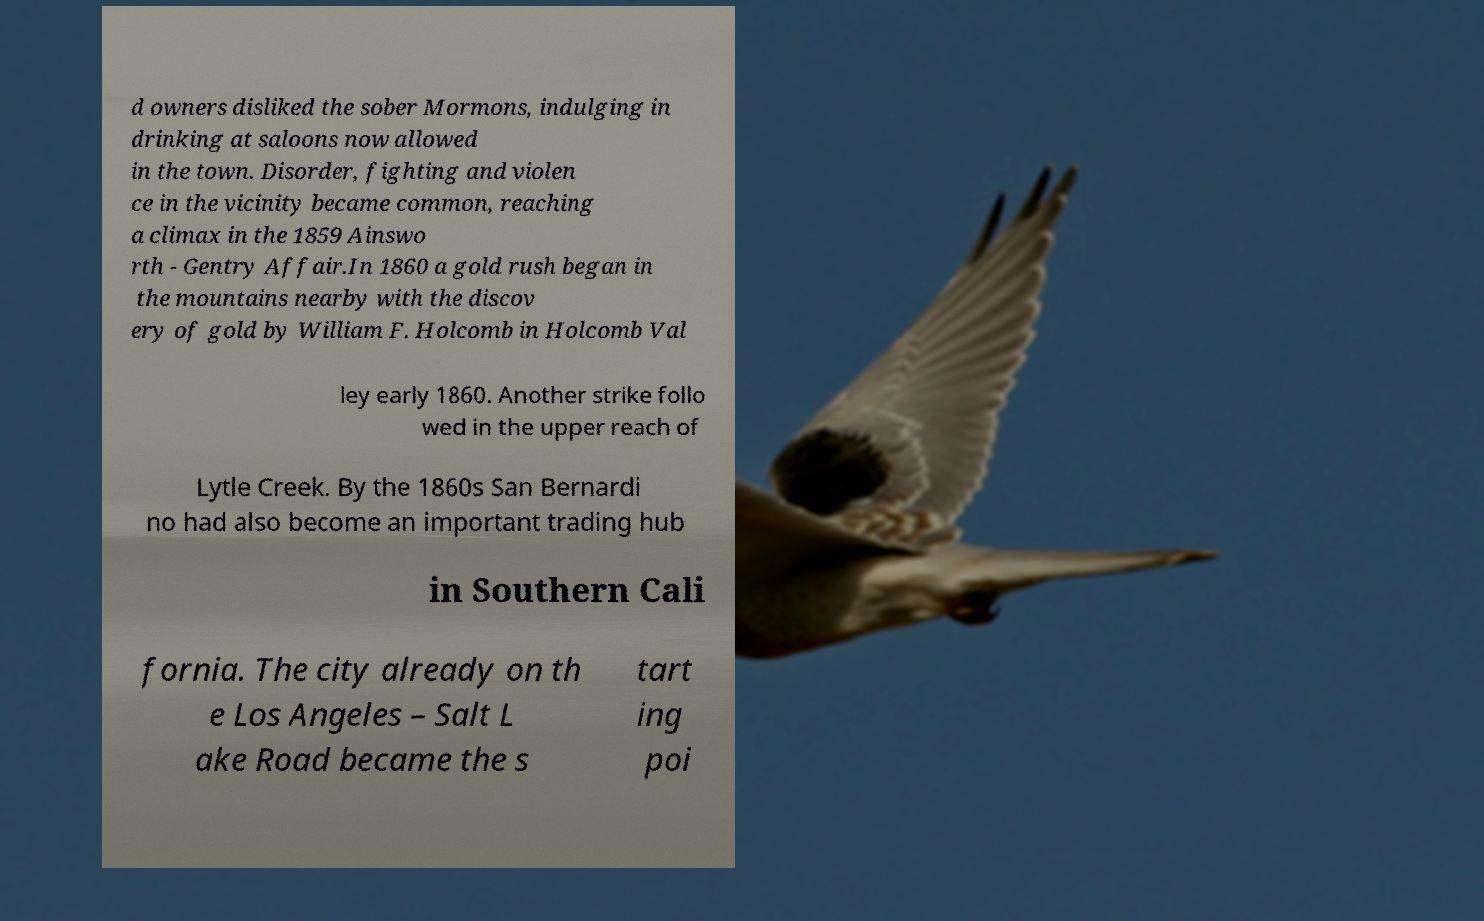Can you accurately transcribe the text from the provided image for me? d owners disliked the sober Mormons, indulging in drinking at saloons now allowed in the town. Disorder, fighting and violen ce in the vicinity became common, reaching a climax in the 1859 Ainswo rth - Gentry Affair.In 1860 a gold rush began in the mountains nearby with the discov ery of gold by William F. Holcomb in Holcomb Val ley early 1860. Another strike follo wed in the upper reach of Lytle Creek. By the 1860s San Bernardi no had also become an important trading hub in Southern Cali fornia. The city already on th e Los Angeles – Salt L ake Road became the s tart ing poi 